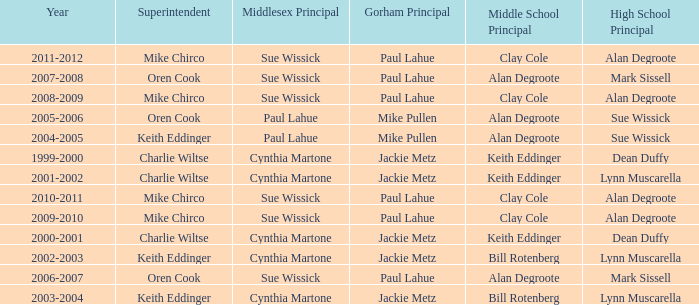Who were the superintendent(s) when the middle school principal was alan degroote, the gorham principal was paul lahue, and the year was 2006-2007? Oren Cook. 